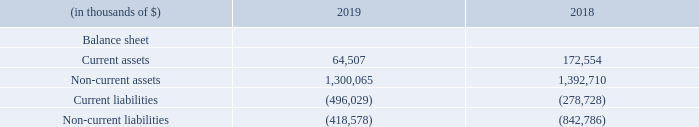Summarized financial information of Hilli LLC
The assets and liabilities of Hilli LLC(1) that most significantly impacted our consolidated balance sheet as of December 31, 2019 and 2018, are as follows:
(1) As Hilli LLC is the primary beneficiary of the Hilli Lessor VIE (see above) the Hilli LLC balances include the Hilli Lessor VIE.
In which years was the assets and liabilities recorded for? 2019, 2018. Who is the primary beneficiary of the Hilli Lessor VIE ? Hilli llc. What was the current liabilities in 2018?
Answer scale should be: thousand. (278,728). Which year was the non-current liabilities higher? (842,786) > (418,578)
Answer: 2018. What was the change in current assets between 2018 and 2019?
Answer scale should be: thousand. 64,507 - 172,554 
Answer: -108047. What was the percentage change in non-current assets between 2018 and 2019?
Answer scale should be: percent. (1,300,065 - 1,392,710)/1,392,710 
Answer: -6.65. 